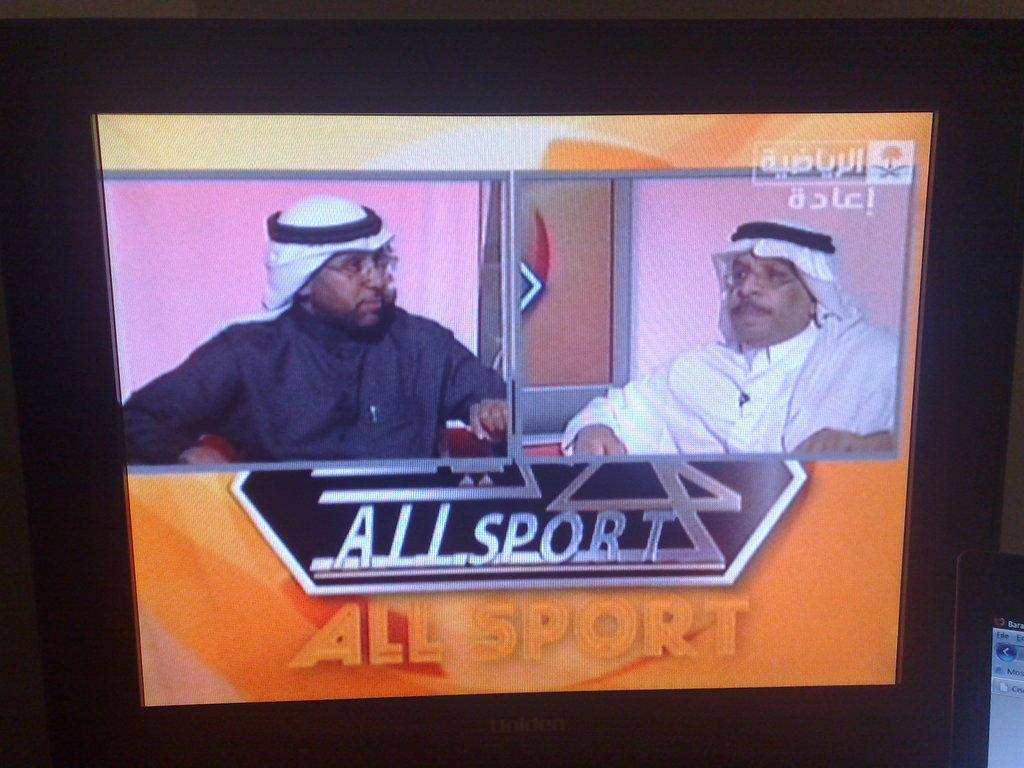Provide a one-sentence caption for the provided image. The television show All Sport features two men on a split screen. 